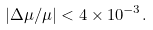Convert formula to latex. <formula><loc_0><loc_0><loc_500><loc_500>| \Delta \mu / \mu | < 4 \times 1 0 ^ { - 3 } .</formula> 